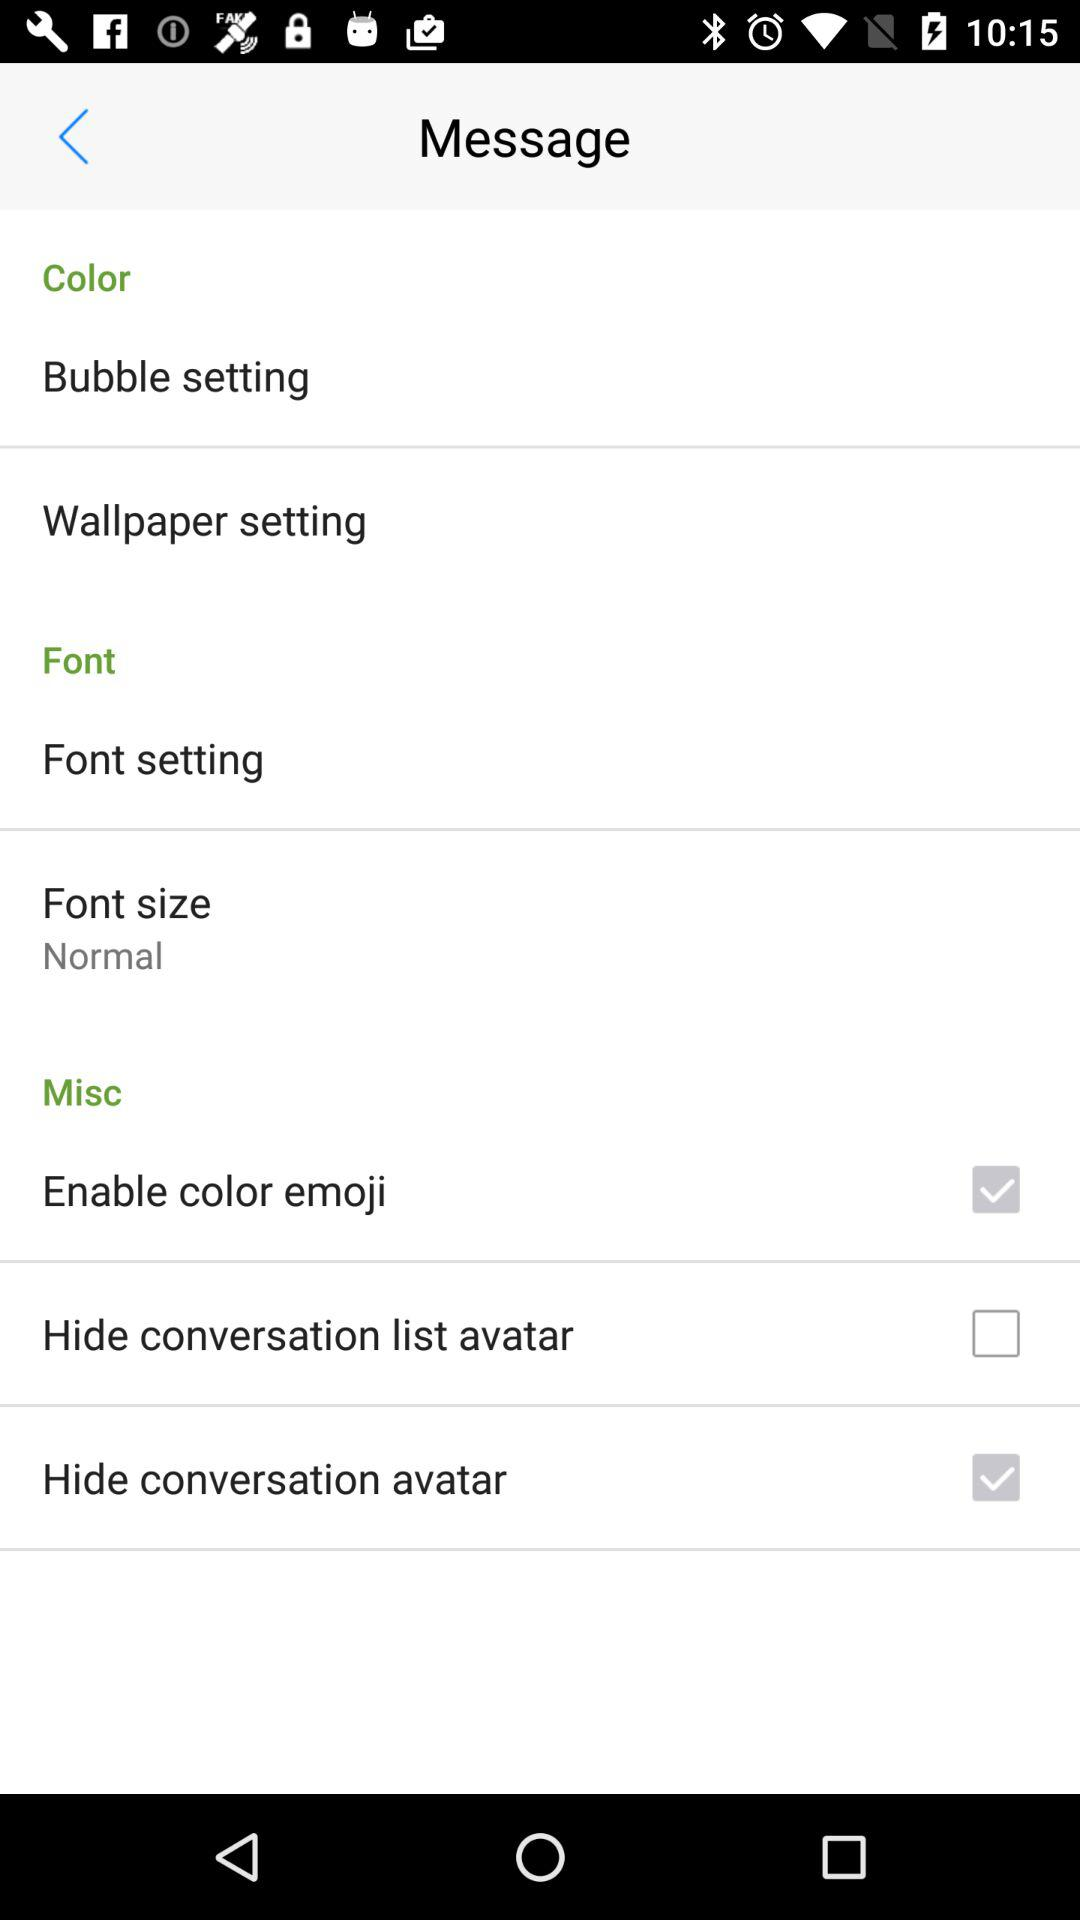What is the status of "Enable color emoji"? The status is "on". 